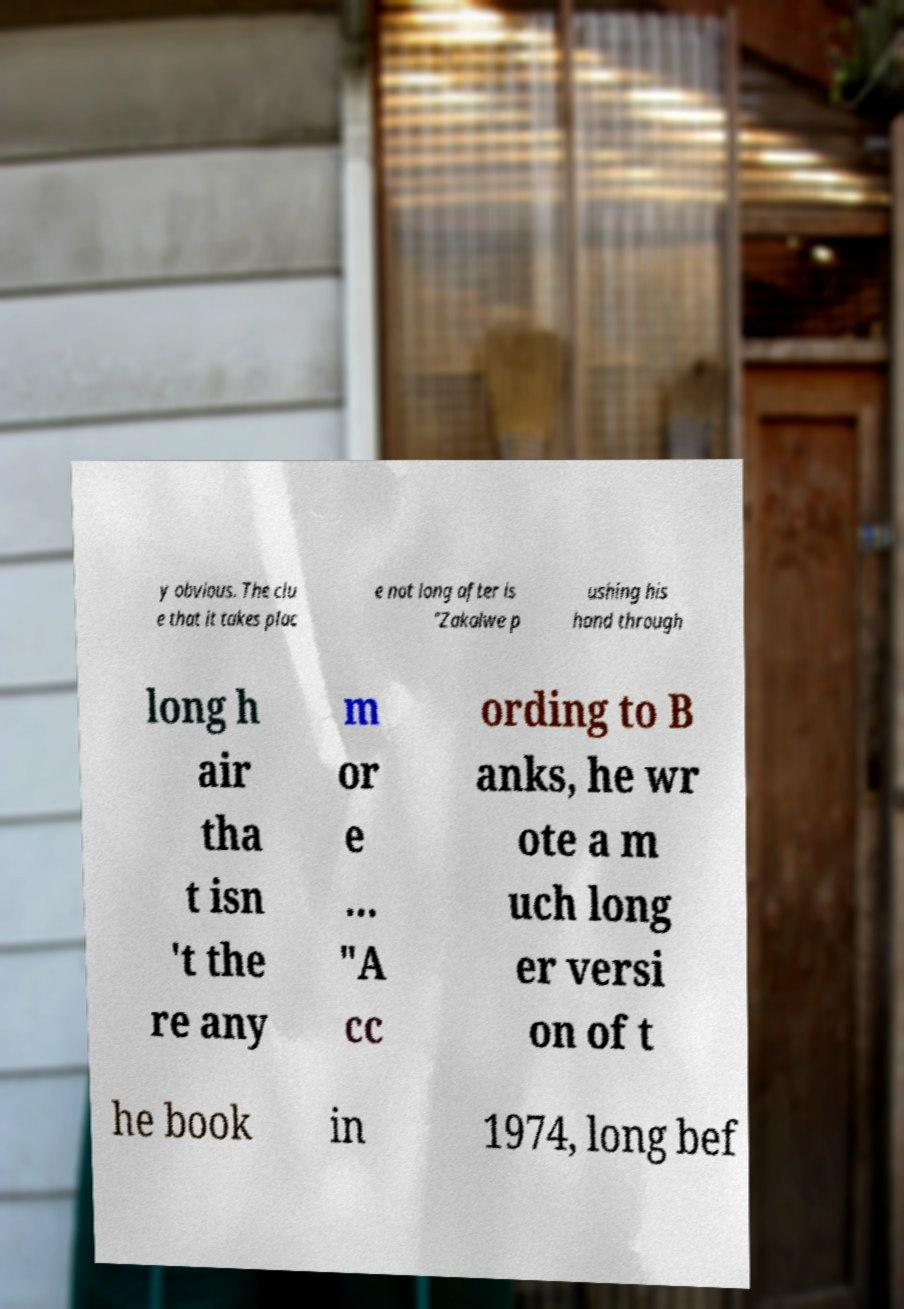Please identify and transcribe the text found in this image. y obvious. The clu e that it takes plac e not long after is "Zakalwe p ushing his hand through long h air tha t isn 't the re any m or e … "A cc ording to B anks, he wr ote a m uch long er versi on of t he book in 1974, long bef 